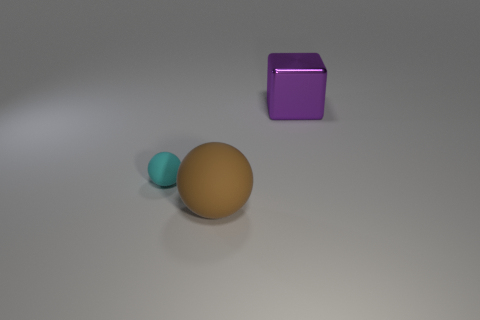Are there any tiny spheres that have the same material as the brown object?
Offer a very short reply. Yes. What color is the large thing that is in front of the big object that is right of the large thing that is in front of the purple metallic object?
Your answer should be compact. Brown. How many purple objects are big objects or large metallic things?
Make the answer very short. 1. What number of other brown matte objects are the same shape as the large brown object?
Offer a very short reply. 0. There is a purple thing that is the same size as the brown ball; what is its shape?
Keep it short and to the point. Cube. There is a big purple metallic thing; are there any metal objects left of it?
Offer a very short reply. No. Are there any balls that are behind the big thing that is left of the large block?
Make the answer very short. Yes. Is the number of purple shiny cubes in front of the small cyan rubber sphere less than the number of purple things that are on the left side of the big metal object?
Offer a very short reply. No. Is there anything else that has the same size as the cyan rubber sphere?
Keep it short and to the point. No. What is the shape of the large brown rubber object?
Give a very brief answer. Sphere. 